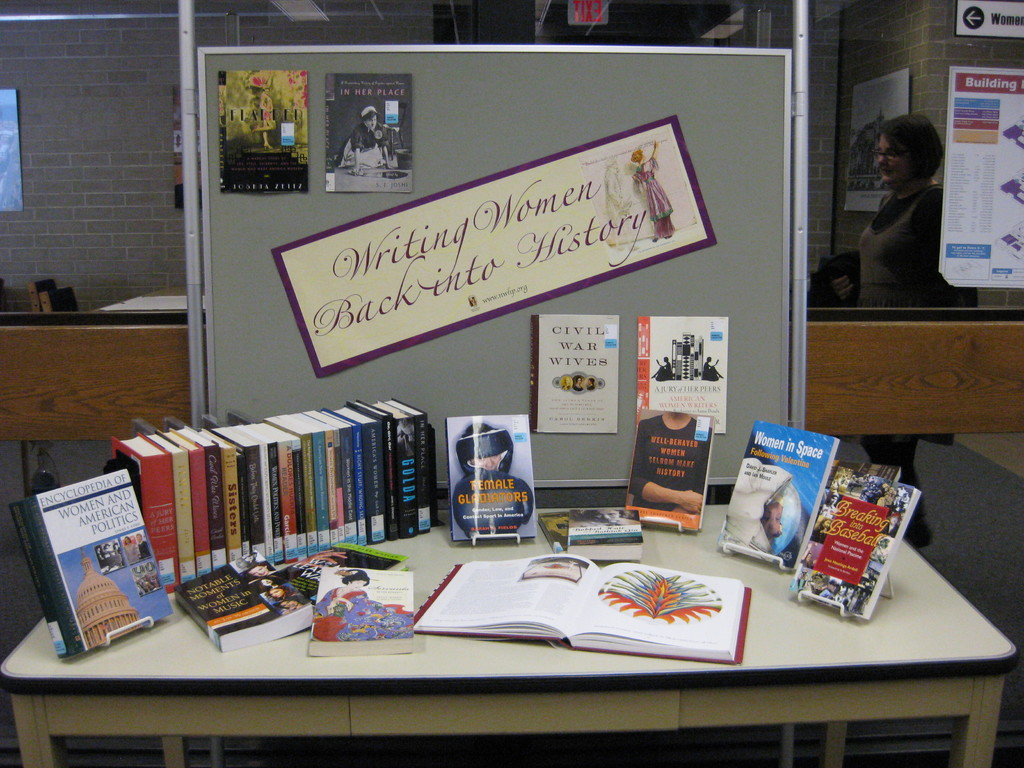Could you describe some of the books and topics featured in this exhibition? Certainly! The exhibition includes a variety of titles such as 'Encyclopedia of Women and American Politics,' which provides a comprehensive look at the involvement of women in US politics, and 'Women in Space,' which delves into the contributions of women in the field of space exploration. These books cover historical achievements and modern challenges faced by women in these fields. Are there any specific historical figures or periods that these books focus on? Yes, some books specifically focus on significant figures and periods. For example, 'Civil War Wives' offers insights into the lives of women during the American Civil War, exploring their roles and hardships. Another book, 'Almighty Justice Pains,' might detail the legal struggles and triumphs of women throughout various periods in history, although the exact topic isn't clearly visible. 